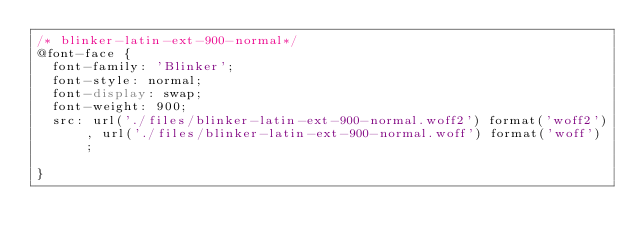<code> <loc_0><loc_0><loc_500><loc_500><_CSS_>/* blinker-latin-ext-900-normal*/
@font-face {
  font-family: 'Blinker';
  font-style: normal;
  font-display: swap;
  font-weight: 900;
  src: url('./files/blinker-latin-ext-900-normal.woff2') format('woff2'), url('./files/blinker-latin-ext-900-normal.woff') format('woff');
  
}
</code> 